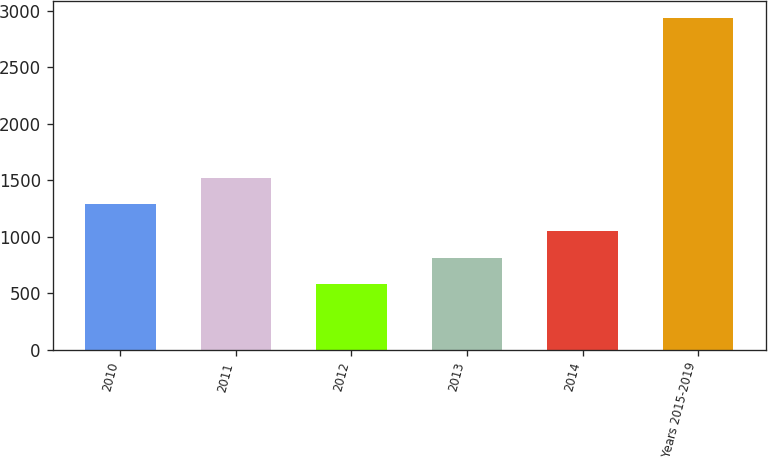Convert chart. <chart><loc_0><loc_0><loc_500><loc_500><bar_chart><fcel>2010<fcel>2011<fcel>2012<fcel>2013<fcel>2014<fcel>Years 2015-2019<nl><fcel>1284.9<fcel>1521.2<fcel>576<fcel>812.3<fcel>1048.6<fcel>2939<nl></chart> 